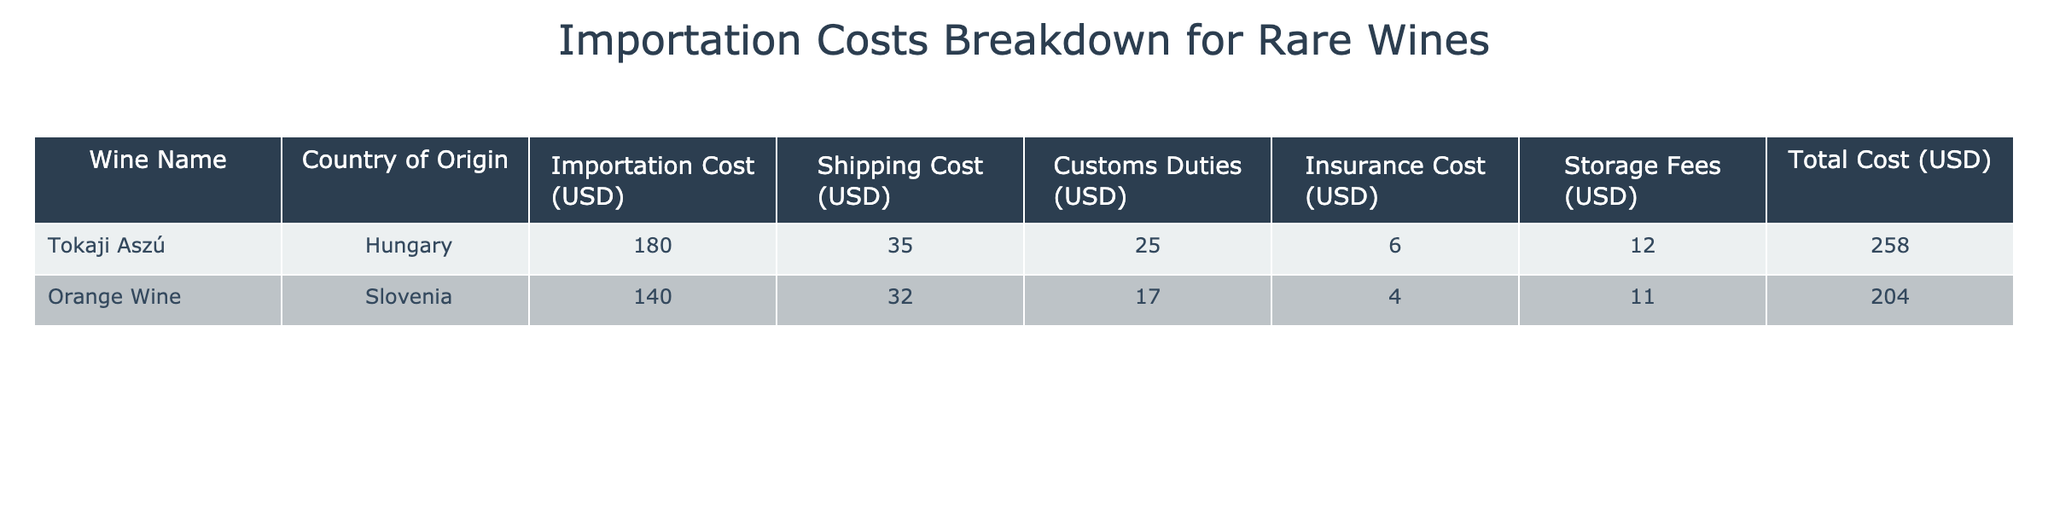What is the total importation cost for Tokaji Aszú? The importation cost for Tokaji Aszú is listed as 180 USD in the table.
Answer: 180 USD What are the shipping costs for Orange Wine? The shipping cost for Orange Wine is provided in the table as 32 USD.
Answer: 32 USD Which wine has a higher total cost, Tokaji Aszú or Orange Wine? To determine the higher total cost, we compare the total costs: Tokaji Aszú has a total cost of 258 USD, while Orange Wine has a total cost of 204 USD. Thus, Tokaji Aszú has the higher total cost.
Answer: Tokaji Aszú Is the insurance cost for Tokaji Aszú greater than the customs duties for Orange Wine? The insurance cost for Tokaji Aszú is 6 USD and the customs duties for Orange Wine are 17 USD. Since 6 is not greater than 17, the statement is false.
Answer: No What is the average storage fee across both wines? The storage fees for Tokaji Aszú and Orange Wine are 12 USD and 11 USD, respectively. To find the average, we sum these fees (12 + 11 = 23) and divide by the number of wines (2). Hence, the average storage fee is 23 / 2 = 11.5 USD.
Answer: 11.5 USD What is the total cost of shipping and insurance for both wines combined? The shipping costs are 35 USD for Tokaji Aszú and 32 USD for Orange Wine, giving a total shipping cost of 35 + 32 = 67 USD. The insurance costs are 6 USD and 4 USD, totaling 6 + 4 = 10 USD. Therefore, the combined total of shipping and insurance costs is 67 + 10 = 77 USD.
Answer: 77 USD Is there a wine from Slovenia in the table? The table includes a wine named Orange Wine, which is from Slovenia. Therefore, the statement is true.
Answer: Yes What is the difference in total costs between Tokaji Aszú and Orange Wine? The total cost for Tokaji Aszú is 258 USD and for Orange Wine, it is 204 USD. To find the difference, we subtract the total cost of Orange Wine from that of Tokaji Aszú (258 - 204 = 54). Thus, the difference is 54 USD.
Answer: 54 USD Which country of origin has the highest importation cost listed? We have the wines from Hungary (Tokaji Aszú) and Slovenia (Orange Wine) with importation costs of 180 USD and 140 USD, respectively. Since 180 is greater than 140, Hungary has the highest importation cost.
Answer: Hungary 